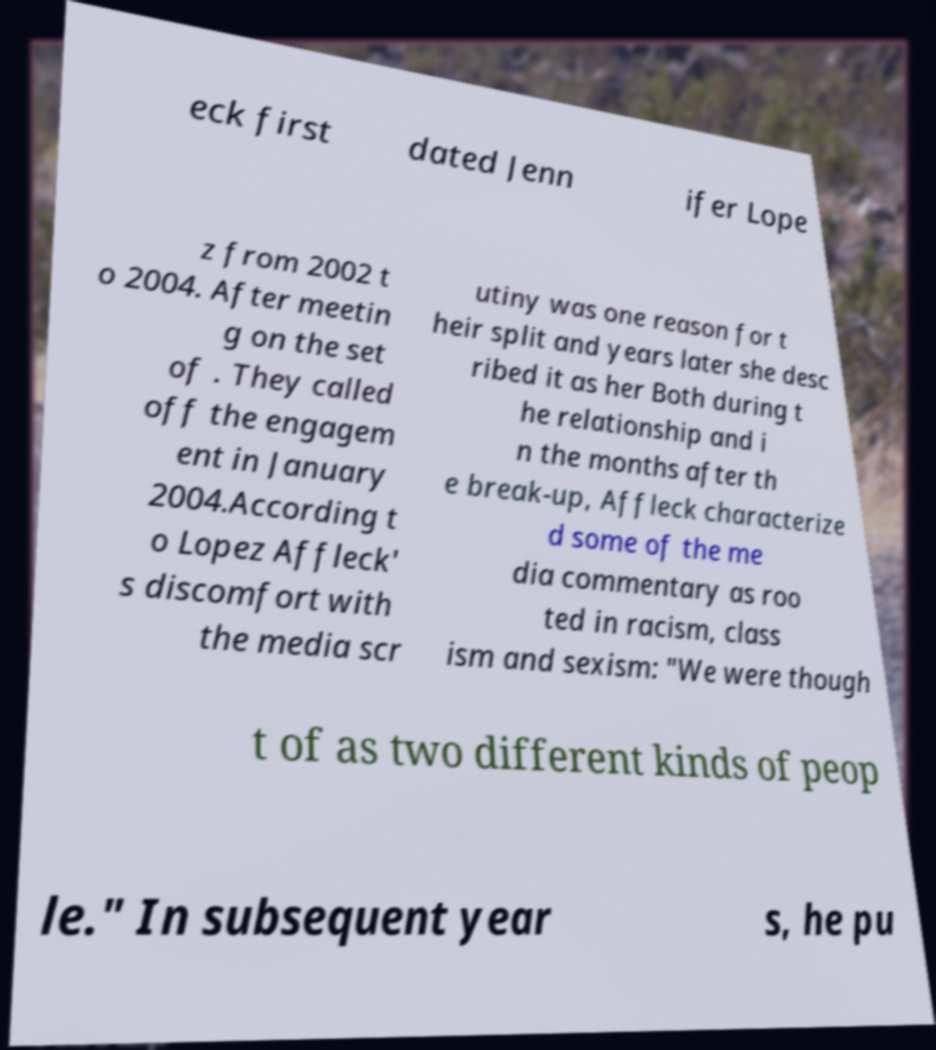What messages or text are displayed in this image? I need them in a readable, typed format. eck first dated Jenn ifer Lope z from 2002 t o 2004. After meetin g on the set of . They called off the engagem ent in January 2004.According t o Lopez Affleck' s discomfort with the media scr utiny was one reason for t heir split and years later she desc ribed it as her Both during t he relationship and i n the months after th e break-up, Affleck characterize d some of the me dia commentary as roo ted in racism, class ism and sexism: "We were though t of as two different kinds of peop le." In subsequent year s, he pu 